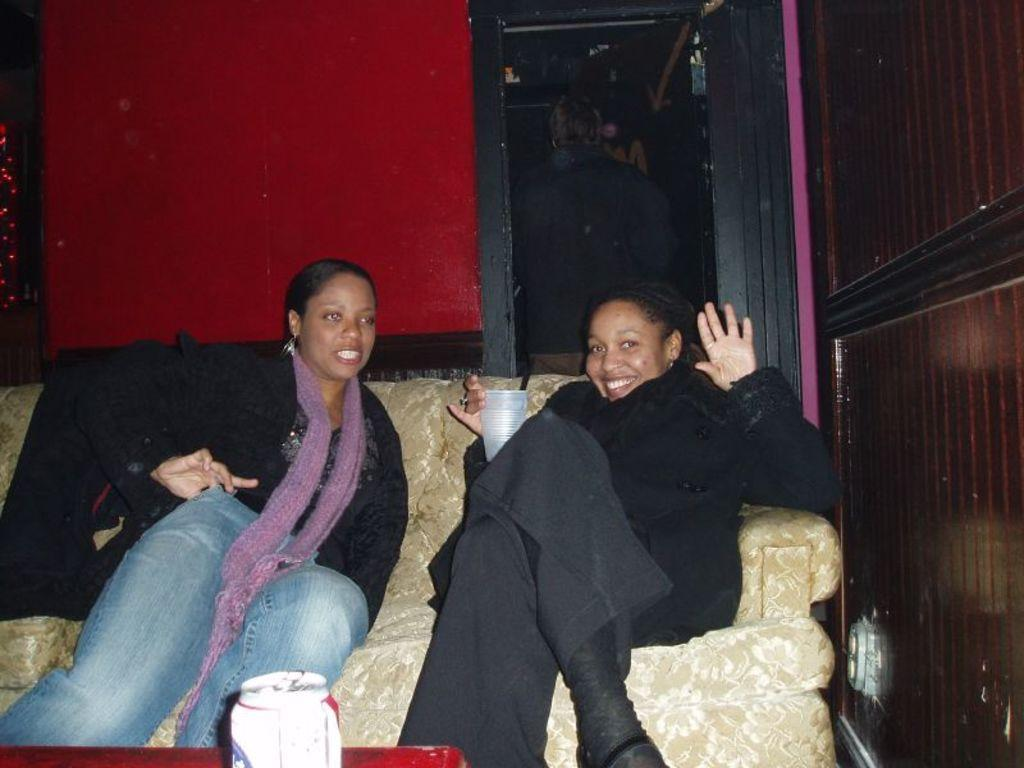How many women are in the image? There are two women in the image. What are the women doing in the image? The women are sitting on a couch. What object is the tin placed on at the bottom of the image? The tin is placed on an object at the bottom of the image, but the specific object is not mentioned in the facts. What is the position of the person standing behind the women? There is a person standing behind the women. What can be seen in the background of the image? There is a wall visible in the image. What is the actor's name who is joining the women in the image? There is no actor or indication of someone joining the women in the image. What is the women's fear in the image? There is no fear mentioned or depicted in the image. 